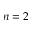Convert formula to latex. <formula><loc_0><loc_0><loc_500><loc_500>n = 2</formula> 